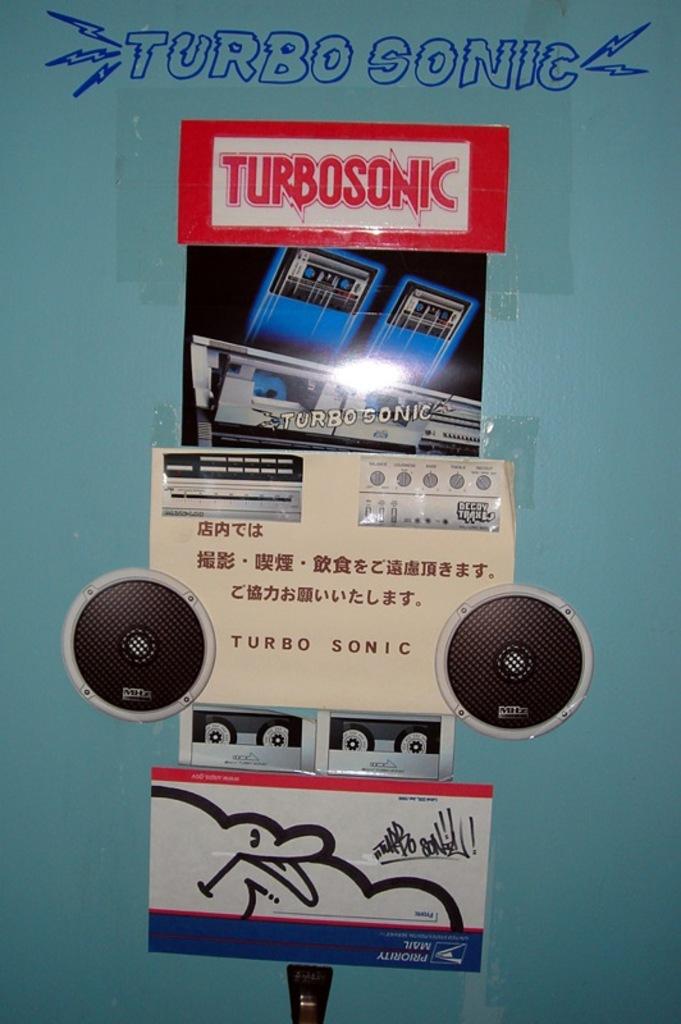Is the language mandarin?
Ensure brevity in your answer.  Yes. Is turbosonic a speaker?
Offer a very short reply. Yes. 